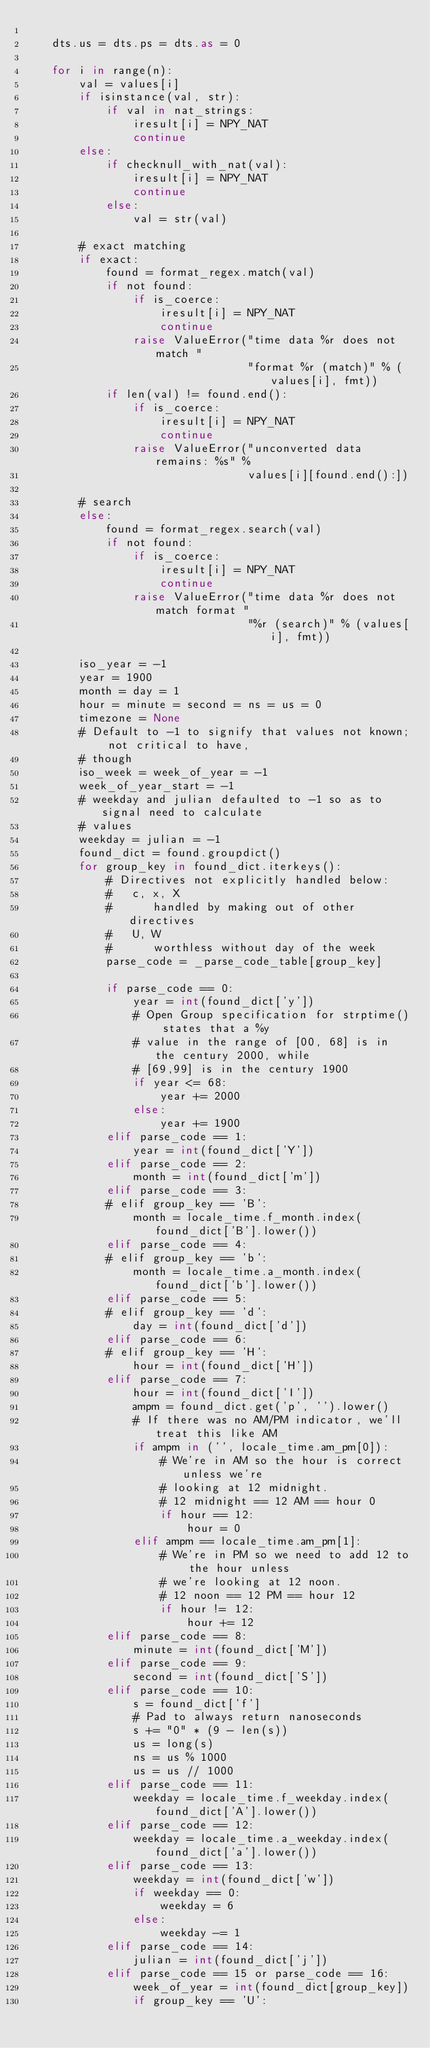<code> <loc_0><loc_0><loc_500><loc_500><_Cython_>
    dts.us = dts.ps = dts.as = 0

    for i in range(n):
        val = values[i]
        if isinstance(val, str):
            if val in nat_strings:
                iresult[i] = NPY_NAT
                continue
        else:
            if checknull_with_nat(val):
                iresult[i] = NPY_NAT
                continue
            else:
                val = str(val)

        # exact matching
        if exact:
            found = format_regex.match(val)
            if not found:
                if is_coerce:
                    iresult[i] = NPY_NAT
                    continue
                raise ValueError("time data %r does not match "
                                 "format %r (match)" % (values[i], fmt))
            if len(val) != found.end():
                if is_coerce:
                    iresult[i] = NPY_NAT
                    continue
                raise ValueError("unconverted data remains: %s" %
                                 values[i][found.end():])

        # search
        else:
            found = format_regex.search(val)
            if not found:
                if is_coerce:
                    iresult[i] = NPY_NAT
                    continue
                raise ValueError("time data %r does not match format "
                                 "%r (search)" % (values[i], fmt))

        iso_year = -1
        year = 1900
        month = day = 1
        hour = minute = second = ns = us = 0
        timezone = None
        # Default to -1 to signify that values not known; not critical to have,
        # though
        iso_week = week_of_year = -1
        week_of_year_start = -1
        # weekday and julian defaulted to -1 so as to signal need to calculate
        # values
        weekday = julian = -1
        found_dict = found.groupdict()
        for group_key in found_dict.iterkeys():
            # Directives not explicitly handled below:
            #   c, x, X
            #      handled by making out of other directives
            #   U, W
            #      worthless without day of the week
            parse_code = _parse_code_table[group_key]

            if parse_code == 0:
                year = int(found_dict['y'])
                # Open Group specification for strptime() states that a %y
                # value in the range of [00, 68] is in the century 2000, while
                # [69,99] is in the century 1900
                if year <= 68:
                    year += 2000
                else:
                    year += 1900
            elif parse_code == 1:
                year = int(found_dict['Y'])
            elif parse_code == 2:
                month = int(found_dict['m'])
            elif parse_code == 3:
            # elif group_key == 'B':
                month = locale_time.f_month.index(found_dict['B'].lower())
            elif parse_code == 4:
            # elif group_key == 'b':
                month = locale_time.a_month.index(found_dict['b'].lower())
            elif parse_code == 5:
            # elif group_key == 'd':
                day = int(found_dict['d'])
            elif parse_code == 6:
            # elif group_key == 'H':
                hour = int(found_dict['H'])
            elif parse_code == 7:
                hour = int(found_dict['I'])
                ampm = found_dict.get('p', '').lower()
                # If there was no AM/PM indicator, we'll treat this like AM
                if ampm in ('', locale_time.am_pm[0]):
                    # We're in AM so the hour is correct unless we're
                    # looking at 12 midnight.
                    # 12 midnight == 12 AM == hour 0
                    if hour == 12:
                        hour = 0
                elif ampm == locale_time.am_pm[1]:
                    # We're in PM so we need to add 12 to the hour unless
                    # we're looking at 12 noon.
                    # 12 noon == 12 PM == hour 12
                    if hour != 12:
                        hour += 12
            elif parse_code == 8:
                minute = int(found_dict['M'])
            elif parse_code == 9:
                second = int(found_dict['S'])
            elif parse_code == 10:
                s = found_dict['f']
                # Pad to always return nanoseconds
                s += "0" * (9 - len(s))
                us = long(s)
                ns = us % 1000
                us = us // 1000
            elif parse_code == 11:
                weekday = locale_time.f_weekday.index(found_dict['A'].lower())
            elif parse_code == 12:
                weekday = locale_time.a_weekday.index(found_dict['a'].lower())
            elif parse_code == 13:
                weekday = int(found_dict['w'])
                if weekday == 0:
                    weekday = 6
                else:
                    weekday -= 1
            elif parse_code == 14:
                julian = int(found_dict['j'])
            elif parse_code == 15 or parse_code == 16:
                week_of_year = int(found_dict[group_key])
                if group_key == 'U':</code> 